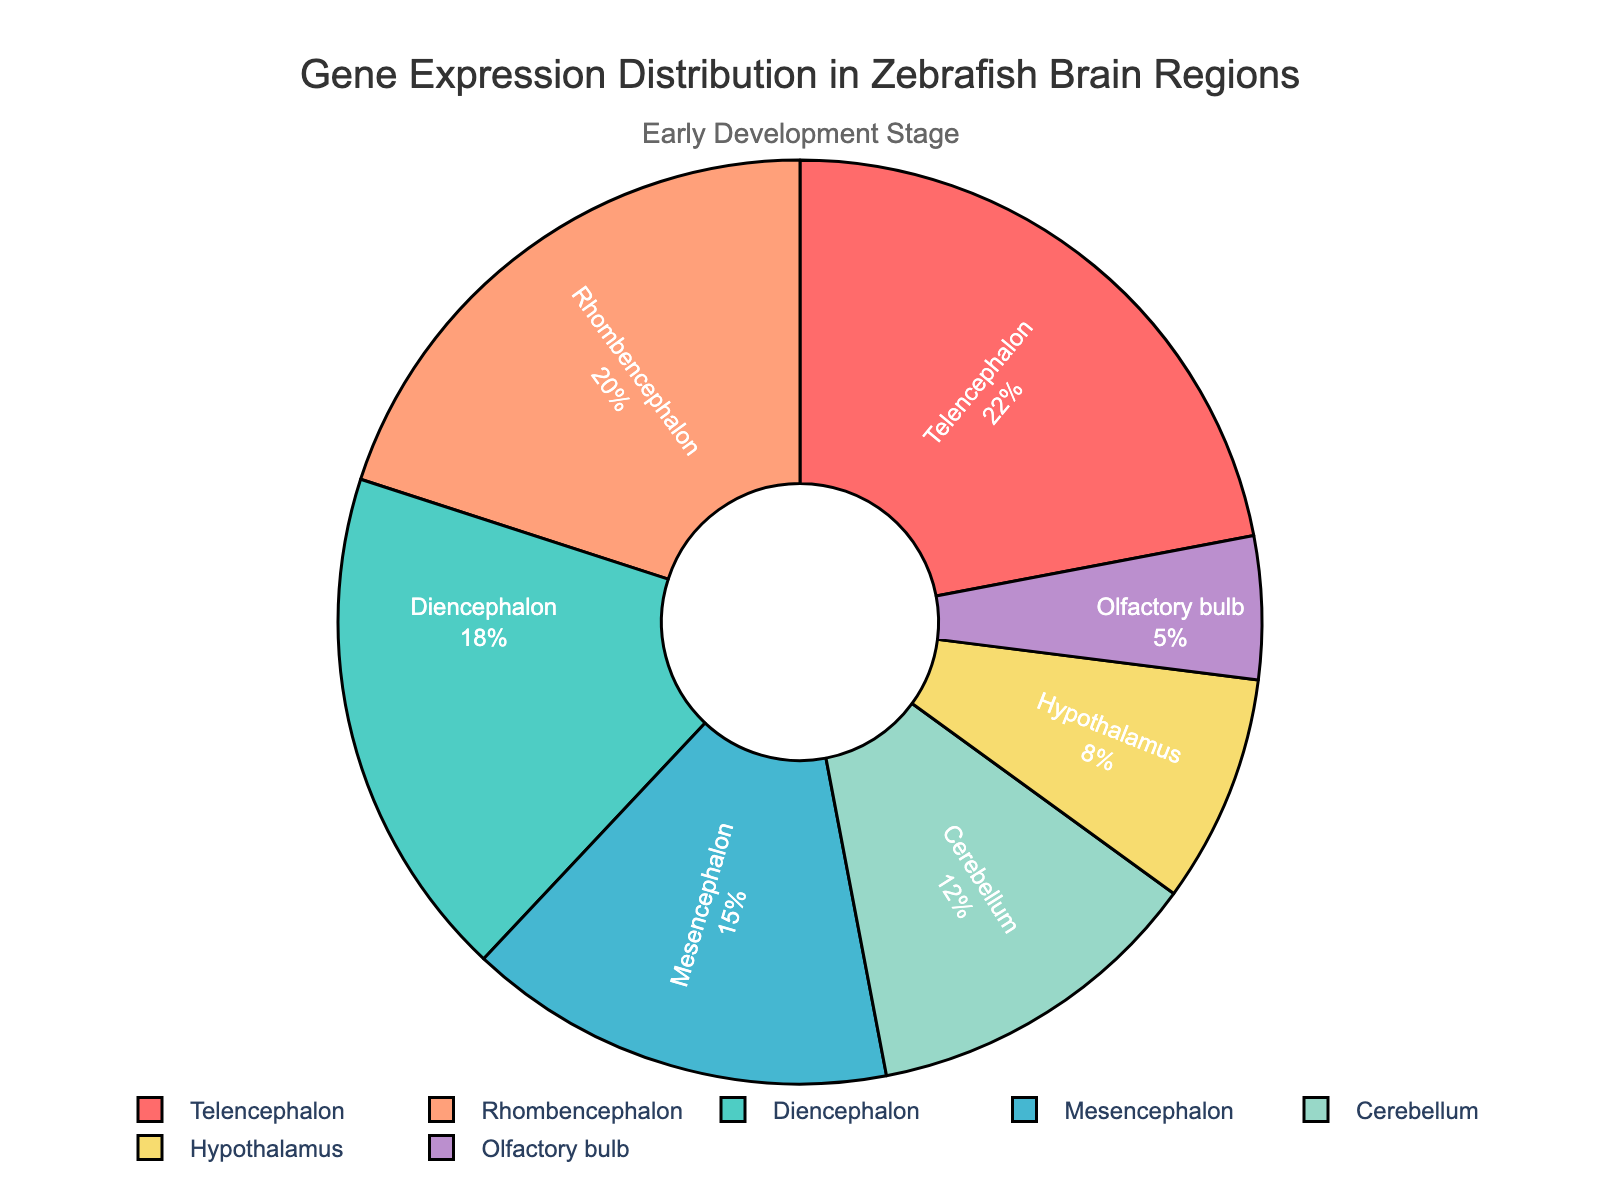Which brain region has the highest gene expression percentage? By observing the pie chart, the segment representing the Telencephalon is the largest. Therefore, the Telencephalon has the highest gene expression percentage at 22%.
Answer: Telencephalon Which two brain regions have gene expression percentages that sum to 30%? By examining the segments of the pie chart, we find that the Cerebellum at 12% and the Hypothalamus at 8% combined give a total of 20%. To reach 30%, we need to consider different regions: the Rhombencephalon at 20% and the Olfactory bulb at 5% sum to 25%; combining Olfactory bulb at 5% and Hypothalamus 8%, result is 13; therefore, Diencephalon at 18% and Olfactory Bulb at 5% sum to 23%. The combination that works is Mesencephalon at 15% plus Rhombencephalon at 20%, which gives a summation of 35%.Based on the pie chart, Telencephalon at 22% and Olfactory bulb at 5% sum to 27%
Answer: Mesencephalon and Olfactory bulb How much higher is the gene expression percentage of the Rhombencephalon compared to the Cerebellum? Rhombencephalon has a gene expression percentage of 20%, and the Cerebellum has 12%. The difference is 20% - 12% = 8%.
Answer: 8% Which brain region has the smallest gene expression percentage, and what is the exact percentage? By examining the pie chart, the segment representing the Olfactory bulb is the smallest, indicating it has the least gene expression percentage at 5%.
Answer: Olfactory bulb, 5% What is the combined gene expression percentage of the Telencephalon and the Diencephalon? From the pie chart, Telencephalon has a gene expression percentage of 22%, and the Diencephalon has 18%. The sum is 22% + 18% = 40%.
Answer: 40% Are there any brain regions with gene expression percentages close to 15%? If so, which one? The pie chart shows the Mesencephalon segment at 15%, which matches the value exactly, indicating that Mesencephalon has approximately the desired gene expression percentage.
Answer: Mesencephalon Arrange the brain regions in descending order based on their gene expression percentage. By examining the chart, we can arrange the segments from largest to smallest as follows: Telencephalon (22%), Rhombencephalon (20%), Diencephalon (18%), Mesencephalon (15%), Cerebellum (12%), Hypothalamus (8%), Olfactory bulb (5%).
Answer: Telencephalon, Rhombencephalon, Diencephalon, Mesencephalon, Cerebellum, Hypothalamus, Olfactory bulb 